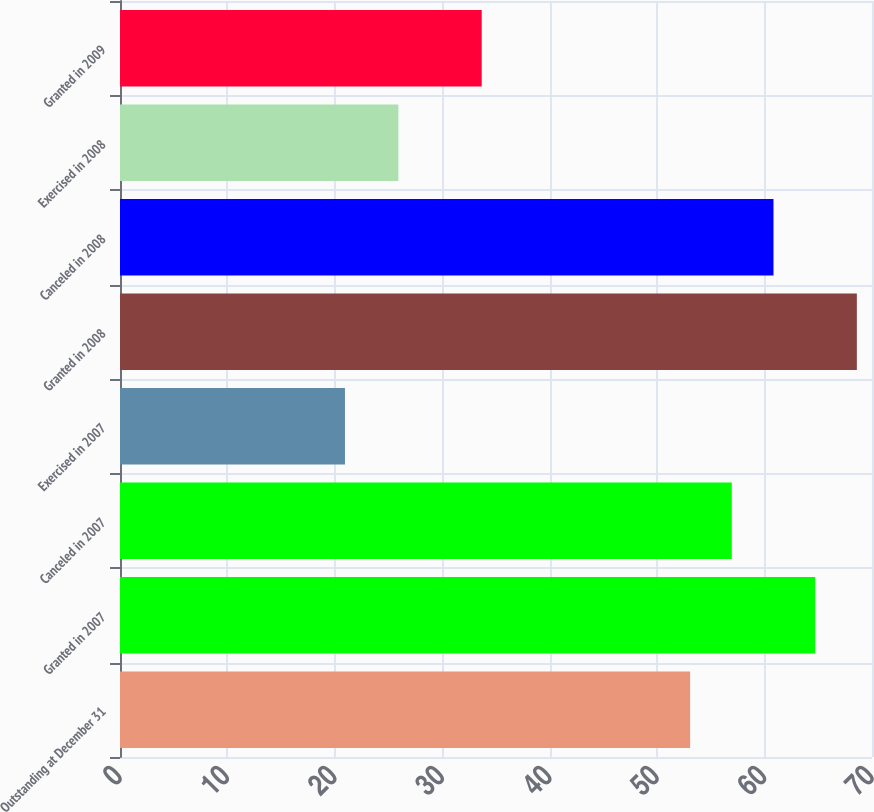Convert chart to OTSL. <chart><loc_0><loc_0><loc_500><loc_500><bar_chart><fcel>Outstanding at December 31<fcel>Granted in 2007<fcel>Canceled in 2007<fcel>Exercised in 2007<fcel>Granted in 2008<fcel>Canceled in 2008<fcel>Exercised in 2008<fcel>Granted in 2009<nl><fcel>53.07<fcel>64.71<fcel>56.95<fcel>20.94<fcel>68.59<fcel>60.83<fcel>25.91<fcel>33.67<nl></chart> 